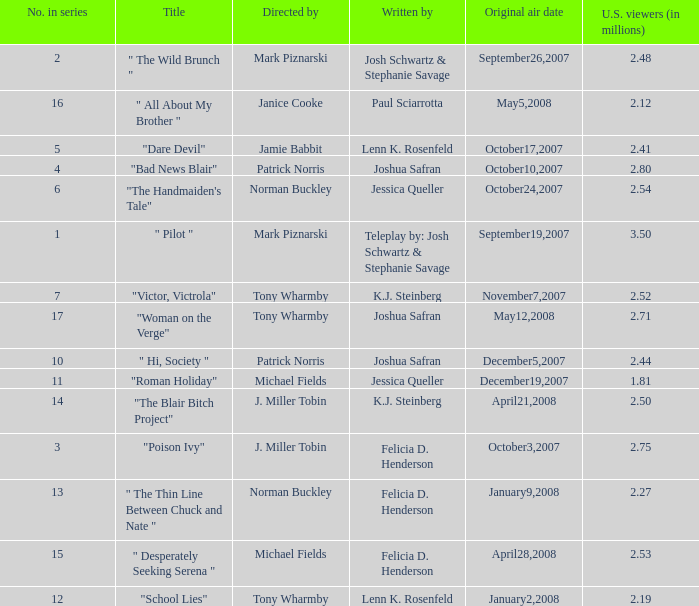How many directed by have 2.80 as u.s. viewers  (in millions)? 1.0. 